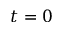Convert formula to latex. <formula><loc_0><loc_0><loc_500><loc_500>t = 0</formula> 